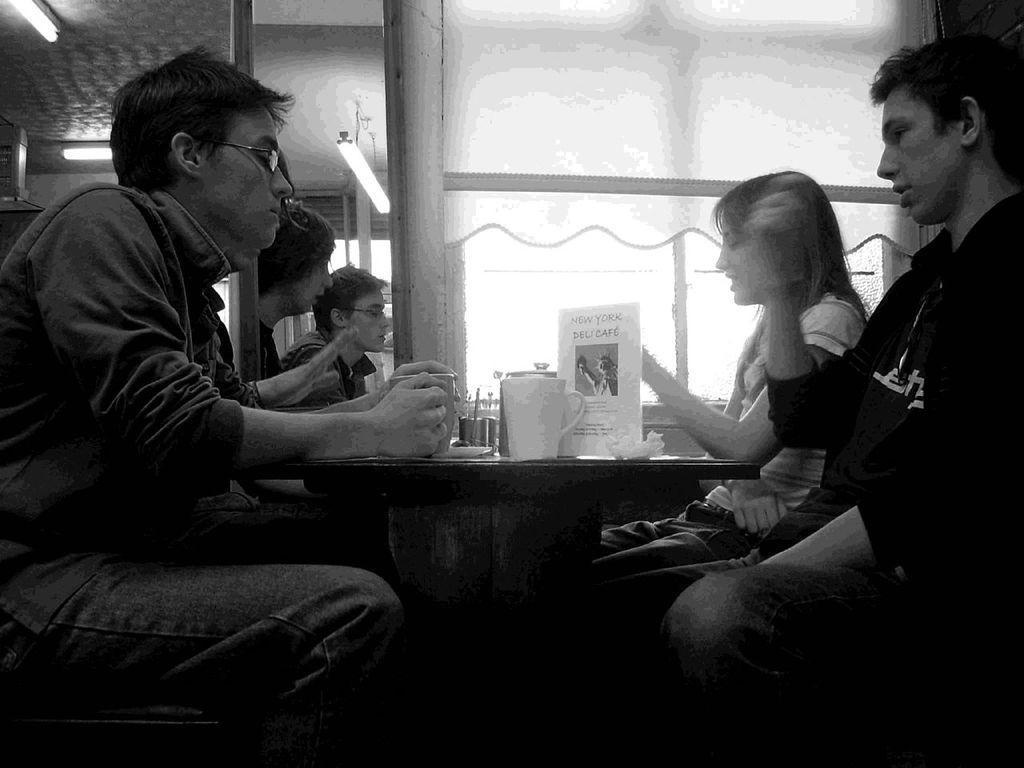Please provide a concise description of this image. There are four people sitting in front of a table. Three of them are men and one is woman. On the table there is a cup. In the background we can observe some windows and curtain. 